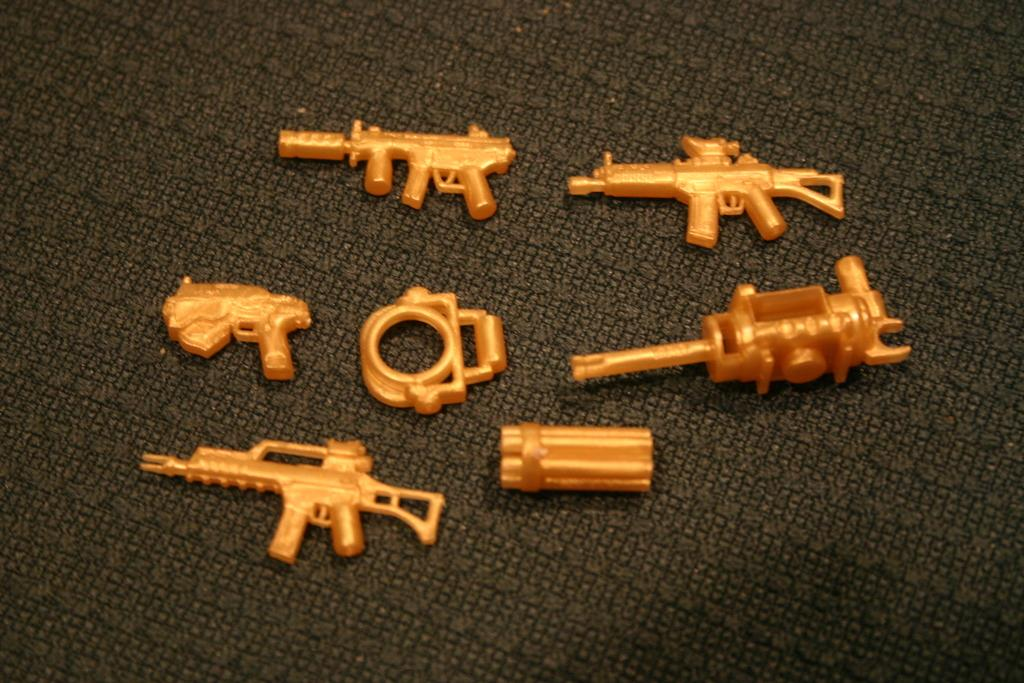What objects are present in the image? There are toys in the image. Where are the toys located? The toys are on a cloth. What type of hammer is being used to stimulate the nerve in the image? There is no hammer or nerve present in the image; it features toys on a cloth. 